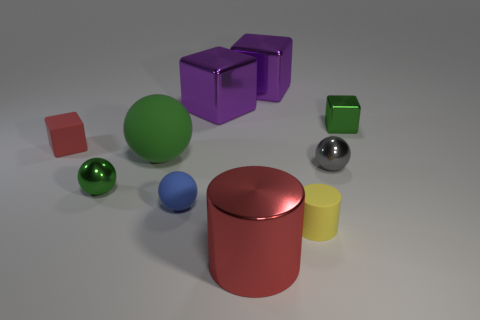Is there anything else that is the same size as the yellow matte object?
Give a very brief answer. Yes. How many other objects are the same shape as the yellow thing?
Give a very brief answer. 1. Do the metallic ball right of the big cylinder and the rubber sphere that is behind the blue object have the same color?
Provide a succinct answer. No. Is the size of the sphere that is in front of the small green ball the same as the metal sphere that is to the right of the tiny yellow matte thing?
Keep it short and to the point. Yes. What material is the cylinder that is behind the large metal object that is in front of the tiny green shiny object that is behind the tiny red cube made of?
Keep it short and to the point. Rubber. Does the small blue matte object have the same shape as the small red object?
Keep it short and to the point. No. There is a tiny gray thing that is the same shape as the blue rubber thing; what material is it?
Give a very brief answer. Metal. How many large spheres are the same color as the tiny metallic block?
Your answer should be compact. 1. What is the size of the gray thing that is made of the same material as the red cylinder?
Keep it short and to the point. Small. What number of gray things are rubber blocks or metallic spheres?
Your response must be concise. 1. 